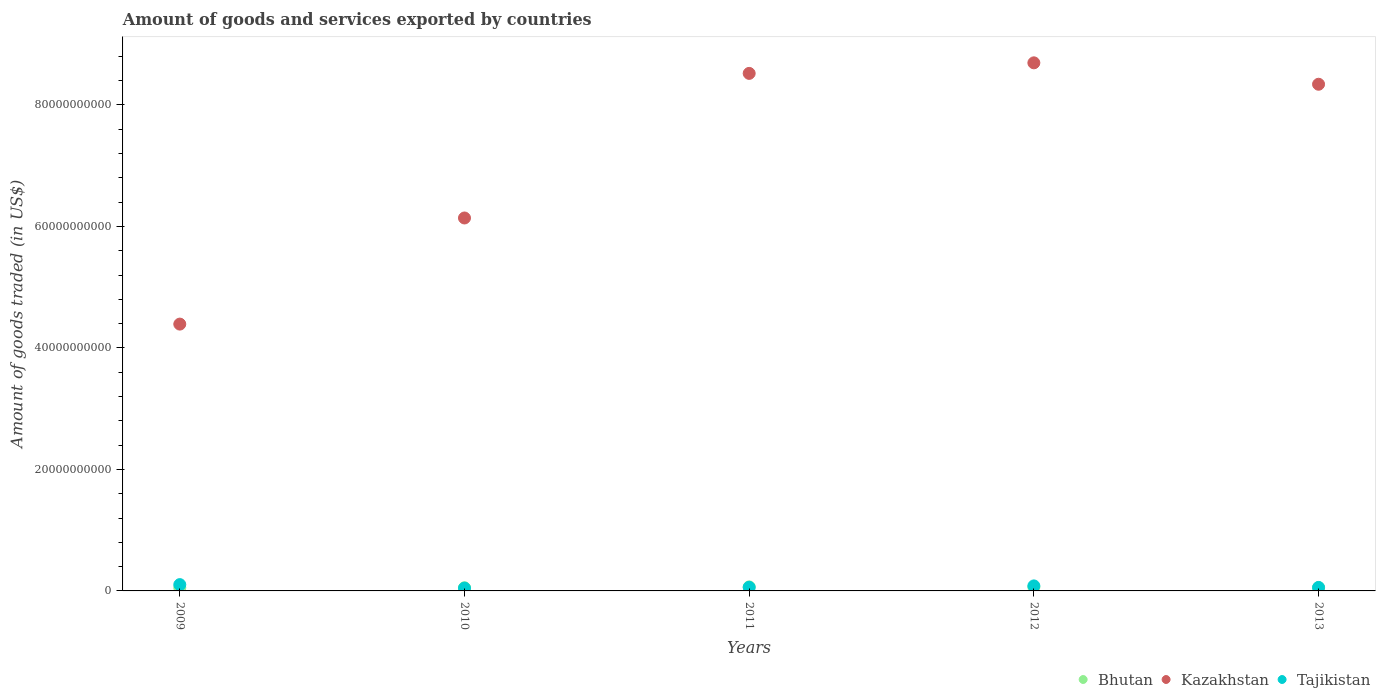What is the total amount of goods and services exported in Tajikistan in 2010?
Offer a very short reply. 4.59e+08. Across all years, what is the maximum total amount of goods and services exported in Kazakhstan?
Give a very brief answer. 8.69e+1. Across all years, what is the minimum total amount of goods and services exported in Tajikistan?
Ensure brevity in your answer.  4.59e+08. What is the total total amount of goods and services exported in Bhutan in the graph?
Give a very brief answer. 2.87e+09. What is the difference between the total amount of goods and services exported in Kazakhstan in 2011 and that in 2013?
Your answer should be compact. 1.79e+09. What is the difference between the total amount of goods and services exported in Tajikistan in 2011 and the total amount of goods and services exported in Kazakhstan in 2010?
Your answer should be compact. -6.08e+1. What is the average total amount of goods and services exported in Kazakhstan per year?
Offer a very short reply. 7.22e+1. In the year 2011, what is the difference between the total amount of goods and services exported in Bhutan and total amount of goods and services exported in Tajikistan?
Provide a succinct answer. 7.03e+07. In how many years, is the total amount of goods and services exported in Tajikistan greater than 24000000000 US$?
Provide a short and direct response. 0. What is the ratio of the total amount of goods and services exported in Kazakhstan in 2012 to that in 2013?
Your answer should be very brief. 1.04. Is the total amount of goods and services exported in Tajikistan in 2011 less than that in 2012?
Your answer should be compact. Yes. What is the difference between the highest and the second highest total amount of goods and services exported in Tajikistan?
Your answer should be very brief. 2.13e+08. What is the difference between the highest and the lowest total amount of goods and services exported in Kazakhstan?
Provide a succinct answer. 4.30e+1. In how many years, is the total amount of goods and services exported in Tajikistan greater than the average total amount of goods and services exported in Tajikistan taken over all years?
Provide a short and direct response. 2. Is the sum of the total amount of goods and services exported in Bhutan in 2010 and 2012 greater than the maximum total amount of goods and services exported in Kazakhstan across all years?
Your answer should be very brief. No. Is it the case that in every year, the sum of the total amount of goods and services exported in Kazakhstan and total amount of goods and services exported in Bhutan  is greater than the total amount of goods and services exported in Tajikistan?
Keep it short and to the point. Yes. Is the total amount of goods and services exported in Bhutan strictly greater than the total amount of goods and services exported in Kazakhstan over the years?
Give a very brief answer. No. How many dotlines are there?
Offer a very short reply. 3. What is the difference between two consecutive major ticks on the Y-axis?
Provide a succinct answer. 2.00e+1. Does the graph contain any zero values?
Ensure brevity in your answer.  No. What is the title of the graph?
Ensure brevity in your answer.  Amount of goods and services exported by countries. What is the label or title of the X-axis?
Make the answer very short. Years. What is the label or title of the Y-axis?
Your response must be concise. Amount of goods traded (in US$). What is the Amount of goods traded (in US$) of Bhutan in 2009?
Give a very brief answer. 5.18e+08. What is the Amount of goods traded (in US$) of Kazakhstan in 2009?
Your answer should be compact. 4.39e+1. What is the Amount of goods traded (in US$) of Tajikistan in 2009?
Make the answer very short. 1.04e+09. What is the Amount of goods traded (in US$) in Bhutan in 2010?
Make the answer very short. 5.22e+08. What is the Amount of goods traded (in US$) in Kazakhstan in 2010?
Offer a very short reply. 6.14e+1. What is the Amount of goods traded (in US$) in Tajikistan in 2010?
Provide a short and direct response. 4.59e+08. What is the Amount of goods traded (in US$) in Bhutan in 2011?
Offer a very short reply. 6.64e+08. What is the Amount of goods traded (in US$) in Kazakhstan in 2011?
Make the answer very short. 8.52e+1. What is the Amount of goods traded (in US$) of Tajikistan in 2011?
Give a very brief answer. 5.93e+08. What is the Amount of goods traded (in US$) of Bhutan in 2012?
Make the answer very short. 6.27e+08. What is the Amount of goods traded (in US$) of Kazakhstan in 2012?
Provide a succinct answer. 8.69e+1. What is the Amount of goods traded (in US$) in Tajikistan in 2012?
Your answer should be compact. 8.26e+08. What is the Amount of goods traded (in US$) in Bhutan in 2013?
Ensure brevity in your answer.  5.44e+08. What is the Amount of goods traded (in US$) of Kazakhstan in 2013?
Ensure brevity in your answer.  8.34e+1. What is the Amount of goods traded (in US$) of Tajikistan in 2013?
Keep it short and to the point. 5.74e+08. Across all years, what is the maximum Amount of goods traded (in US$) of Bhutan?
Give a very brief answer. 6.64e+08. Across all years, what is the maximum Amount of goods traded (in US$) in Kazakhstan?
Your response must be concise. 8.69e+1. Across all years, what is the maximum Amount of goods traded (in US$) in Tajikistan?
Offer a terse response. 1.04e+09. Across all years, what is the minimum Amount of goods traded (in US$) of Bhutan?
Provide a short and direct response. 5.18e+08. Across all years, what is the minimum Amount of goods traded (in US$) in Kazakhstan?
Your answer should be compact. 4.39e+1. Across all years, what is the minimum Amount of goods traded (in US$) of Tajikistan?
Give a very brief answer. 4.59e+08. What is the total Amount of goods traded (in US$) in Bhutan in the graph?
Make the answer very short. 2.87e+09. What is the total Amount of goods traded (in US$) of Kazakhstan in the graph?
Your answer should be very brief. 3.61e+11. What is the total Amount of goods traded (in US$) of Tajikistan in the graph?
Your answer should be very brief. 3.49e+09. What is the difference between the Amount of goods traded (in US$) in Bhutan in 2009 and that in 2010?
Offer a terse response. -3.70e+06. What is the difference between the Amount of goods traded (in US$) of Kazakhstan in 2009 and that in 2010?
Offer a terse response. -1.75e+1. What is the difference between the Amount of goods traded (in US$) in Tajikistan in 2009 and that in 2010?
Keep it short and to the point. 5.79e+08. What is the difference between the Amount of goods traded (in US$) of Bhutan in 2009 and that in 2011?
Provide a succinct answer. -1.46e+08. What is the difference between the Amount of goods traded (in US$) in Kazakhstan in 2009 and that in 2011?
Your answer should be very brief. -4.13e+1. What is the difference between the Amount of goods traded (in US$) in Tajikistan in 2009 and that in 2011?
Offer a terse response. 4.45e+08. What is the difference between the Amount of goods traded (in US$) in Bhutan in 2009 and that in 2012?
Make the answer very short. -1.09e+08. What is the difference between the Amount of goods traded (in US$) of Kazakhstan in 2009 and that in 2012?
Offer a very short reply. -4.30e+1. What is the difference between the Amount of goods traded (in US$) of Tajikistan in 2009 and that in 2012?
Provide a short and direct response. 2.13e+08. What is the difference between the Amount of goods traded (in US$) in Bhutan in 2009 and that in 2013?
Keep it short and to the point. -2.65e+07. What is the difference between the Amount of goods traded (in US$) of Kazakhstan in 2009 and that in 2013?
Your answer should be compact. -3.95e+1. What is the difference between the Amount of goods traded (in US$) in Tajikistan in 2009 and that in 2013?
Keep it short and to the point. 4.64e+08. What is the difference between the Amount of goods traded (in US$) of Bhutan in 2010 and that in 2011?
Your answer should be very brief. -1.42e+08. What is the difference between the Amount of goods traded (in US$) in Kazakhstan in 2010 and that in 2011?
Offer a terse response. -2.38e+1. What is the difference between the Amount of goods traded (in US$) in Tajikistan in 2010 and that in 2011?
Keep it short and to the point. -1.34e+08. What is the difference between the Amount of goods traded (in US$) in Bhutan in 2010 and that in 2012?
Give a very brief answer. -1.05e+08. What is the difference between the Amount of goods traded (in US$) in Kazakhstan in 2010 and that in 2012?
Make the answer very short. -2.55e+1. What is the difference between the Amount of goods traded (in US$) of Tajikistan in 2010 and that in 2012?
Your response must be concise. -3.67e+08. What is the difference between the Amount of goods traded (in US$) in Bhutan in 2010 and that in 2013?
Provide a short and direct response. -2.28e+07. What is the difference between the Amount of goods traded (in US$) in Kazakhstan in 2010 and that in 2013?
Ensure brevity in your answer.  -2.20e+1. What is the difference between the Amount of goods traded (in US$) in Tajikistan in 2010 and that in 2013?
Your response must be concise. -1.15e+08. What is the difference between the Amount of goods traded (in US$) in Bhutan in 2011 and that in 2012?
Provide a short and direct response. 3.68e+07. What is the difference between the Amount of goods traded (in US$) of Kazakhstan in 2011 and that in 2012?
Offer a very short reply. -1.74e+09. What is the difference between the Amount of goods traded (in US$) in Tajikistan in 2011 and that in 2012?
Ensure brevity in your answer.  -2.33e+08. What is the difference between the Amount of goods traded (in US$) in Bhutan in 2011 and that in 2013?
Offer a very short reply. 1.19e+08. What is the difference between the Amount of goods traded (in US$) in Kazakhstan in 2011 and that in 2013?
Your response must be concise. 1.79e+09. What is the difference between the Amount of goods traded (in US$) in Tajikistan in 2011 and that in 2013?
Provide a succinct answer. 1.93e+07. What is the difference between the Amount of goods traded (in US$) in Bhutan in 2012 and that in 2013?
Offer a terse response. 8.24e+07. What is the difference between the Amount of goods traded (in US$) in Kazakhstan in 2012 and that in 2013?
Keep it short and to the point. 3.52e+09. What is the difference between the Amount of goods traded (in US$) in Tajikistan in 2012 and that in 2013?
Your answer should be very brief. 2.52e+08. What is the difference between the Amount of goods traded (in US$) in Bhutan in 2009 and the Amount of goods traded (in US$) in Kazakhstan in 2010?
Make the answer very short. -6.09e+1. What is the difference between the Amount of goods traded (in US$) in Bhutan in 2009 and the Amount of goods traded (in US$) in Tajikistan in 2010?
Provide a short and direct response. 5.88e+07. What is the difference between the Amount of goods traded (in US$) in Kazakhstan in 2009 and the Amount of goods traded (in US$) in Tajikistan in 2010?
Make the answer very short. 4.35e+1. What is the difference between the Amount of goods traded (in US$) in Bhutan in 2009 and the Amount of goods traded (in US$) in Kazakhstan in 2011?
Provide a succinct answer. -8.47e+1. What is the difference between the Amount of goods traded (in US$) in Bhutan in 2009 and the Amount of goods traded (in US$) in Tajikistan in 2011?
Give a very brief answer. -7.54e+07. What is the difference between the Amount of goods traded (in US$) of Kazakhstan in 2009 and the Amount of goods traded (in US$) of Tajikistan in 2011?
Your response must be concise. 4.33e+1. What is the difference between the Amount of goods traded (in US$) in Bhutan in 2009 and the Amount of goods traded (in US$) in Kazakhstan in 2012?
Your response must be concise. -8.64e+1. What is the difference between the Amount of goods traded (in US$) in Bhutan in 2009 and the Amount of goods traded (in US$) in Tajikistan in 2012?
Your answer should be compact. -3.08e+08. What is the difference between the Amount of goods traded (in US$) in Kazakhstan in 2009 and the Amount of goods traded (in US$) in Tajikistan in 2012?
Your answer should be compact. 4.31e+1. What is the difference between the Amount of goods traded (in US$) in Bhutan in 2009 and the Amount of goods traded (in US$) in Kazakhstan in 2013?
Provide a succinct answer. -8.29e+1. What is the difference between the Amount of goods traded (in US$) in Bhutan in 2009 and the Amount of goods traded (in US$) in Tajikistan in 2013?
Your answer should be compact. -5.61e+07. What is the difference between the Amount of goods traded (in US$) in Kazakhstan in 2009 and the Amount of goods traded (in US$) in Tajikistan in 2013?
Your answer should be compact. 4.33e+1. What is the difference between the Amount of goods traded (in US$) in Bhutan in 2010 and the Amount of goods traded (in US$) in Kazakhstan in 2011?
Provide a succinct answer. -8.47e+1. What is the difference between the Amount of goods traded (in US$) in Bhutan in 2010 and the Amount of goods traded (in US$) in Tajikistan in 2011?
Ensure brevity in your answer.  -7.17e+07. What is the difference between the Amount of goods traded (in US$) in Kazakhstan in 2010 and the Amount of goods traded (in US$) in Tajikistan in 2011?
Offer a terse response. 6.08e+1. What is the difference between the Amount of goods traded (in US$) in Bhutan in 2010 and the Amount of goods traded (in US$) in Kazakhstan in 2012?
Offer a very short reply. -8.64e+1. What is the difference between the Amount of goods traded (in US$) of Bhutan in 2010 and the Amount of goods traded (in US$) of Tajikistan in 2012?
Your answer should be compact. -3.04e+08. What is the difference between the Amount of goods traded (in US$) of Kazakhstan in 2010 and the Amount of goods traded (in US$) of Tajikistan in 2012?
Your answer should be compact. 6.06e+1. What is the difference between the Amount of goods traded (in US$) in Bhutan in 2010 and the Amount of goods traded (in US$) in Kazakhstan in 2013?
Offer a very short reply. -8.29e+1. What is the difference between the Amount of goods traded (in US$) in Bhutan in 2010 and the Amount of goods traded (in US$) in Tajikistan in 2013?
Your answer should be compact. -5.24e+07. What is the difference between the Amount of goods traded (in US$) in Kazakhstan in 2010 and the Amount of goods traded (in US$) in Tajikistan in 2013?
Make the answer very short. 6.08e+1. What is the difference between the Amount of goods traded (in US$) of Bhutan in 2011 and the Amount of goods traded (in US$) of Kazakhstan in 2012?
Offer a very short reply. -8.63e+1. What is the difference between the Amount of goods traded (in US$) of Bhutan in 2011 and the Amount of goods traded (in US$) of Tajikistan in 2012?
Make the answer very short. -1.62e+08. What is the difference between the Amount of goods traded (in US$) of Kazakhstan in 2011 and the Amount of goods traded (in US$) of Tajikistan in 2012?
Your answer should be very brief. 8.44e+1. What is the difference between the Amount of goods traded (in US$) in Bhutan in 2011 and the Amount of goods traded (in US$) in Kazakhstan in 2013?
Your response must be concise. -8.27e+1. What is the difference between the Amount of goods traded (in US$) of Bhutan in 2011 and the Amount of goods traded (in US$) of Tajikistan in 2013?
Provide a short and direct response. 8.96e+07. What is the difference between the Amount of goods traded (in US$) in Kazakhstan in 2011 and the Amount of goods traded (in US$) in Tajikistan in 2013?
Keep it short and to the point. 8.46e+1. What is the difference between the Amount of goods traded (in US$) in Bhutan in 2012 and the Amount of goods traded (in US$) in Kazakhstan in 2013?
Keep it short and to the point. -8.28e+1. What is the difference between the Amount of goods traded (in US$) in Bhutan in 2012 and the Amount of goods traded (in US$) in Tajikistan in 2013?
Provide a succinct answer. 5.28e+07. What is the difference between the Amount of goods traded (in US$) of Kazakhstan in 2012 and the Amount of goods traded (in US$) of Tajikistan in 2013?
Your response must be concise. 8.64e+1. What is the average Amount of goods traded (in US$) in Bhutan per year?
Offer a very short reply. 5.75e+08. What is the average Amount of goods traded (in US$) in Kazakhstan per year?
Keep it short and to the point. 7.22e+1. What is the average Amount of goods traded (in US$) in Tajikistan per year?
Provide a succinct answer. 6.98e+08. In the year 2009, what is the difference between the Amount of goods traded (in US$) in Bhutan and Amount of goods traded (in US$) in Kazakhstan?
Keep it short and to the point. -4.34e+1. In the year 2009, what is the difference between the Amount of goods traded (in US$) of Bhutan and Amount of goods traded (in US$) of Tajikistan?
Keep it short and to the point. -5.21e+08. In the year 2009, what is the difference between the Amount of goods traded (in US$) of Kazakhstan and Amount of goods traded (in US$) of Tajikistan?
Your answer should be compact. 4.29e+1. In the year 2010, what is the difference between the Amount of goods traded (in US$) in Bhutan and Amount of goods traded (in US$) in Kazakhstan?
Give a very brief answer. -6.09e+1. In the year 2010, what is the difference between the Amount of goods traded (in US$) of Bhutan and Amount of goods traded (in US$) of Tajikistan?
Keep it short and to the point. 6.25e+07. In the year 2010, what is the difference between the Amount of goods traded (in US$) of Kazakhstan and Amount of goods traded (in US$) of Tajikistan?
Provide a short and direct response. 6.09e+1. In the year 2011, what is the difference between the Amount of goods traded (in US$) of Bhutan and Amount of goods traded (in US$) of Kazakhstan?
Offer a terse response. -8.45e+1. In the year 2011, what is the difference between the Amount of goods traded (in US$) of Bhutan and Amount of goods traded (in US$) of Tajikistan?
Your response must be concise. 7.03e+07. In the year 2011, what is the difference between the Amount of goods traded (in US$) of Kazakhstan and Amount of goods traded (in US$) of Tajikistan?
Provide a succinct answer. 8.46e+1. In the year 2012, what is the difference between the Amount of goods traded (in US$) of Bhutan and Amount of goods traded (in US$) of Kazakhstan?
Ensure brevity in your answer.  -8.63e+1. In the year 2012, what is the difference between the Amount of goods traded (in US$) in Bhutan and Amount of goods traded (in US$) in Tajikistan?
Your answer should be very brief. -1.99e+08. In the year 2012, what is the difference between the Amount of goods traded (in US$) of Kazakhstan and Amount of goods traded (in US$) of Tajikistan?
Your response must be concise. 8.61e+1. In the year 2013, what is the difference between the Amount of goods traded (in US$) in Bhutan and Amount of goods traded (in US$) in Kazakhstan?
Provide a short and direct response. -8.29e+1. In the year 2013, what is the difference between the Amount of goods traded (in US$) of Bhutan and Amount of goods traded (in US$) of Tajikistan?
Offer a very short reply. -2.96e+07. In the year 2013, what is the difference between the Amount of goods traded (in US$) in Kazakhstan and Amount of goods traded (in US$) in Tajikistan?
Ensure brevity in your answer.  8.28e+1. What is the ratio of the Amount of goods traded (in US$) in Kazakhstan in 2009 to that in 2010?
Keep it short and to the point. 0.72. What is the ratio of the Amount of goods traded (in US$) in Tajikistan in 2009 to that in 2010?
Make the answer very short. 2.26. What is the ratio of the Amount of goods traded (in US$) of Bhutan in 2009 to that in 2011?
Provide a succinct answer. 0.78. What is the ratio of the Amount of goods traded (in US$) of Kazakhstan in 2009 to that in 2011?
Give a very brief answer. 0.52. What is the ratio of the Amount of goods traded (in US$) in Tajikistan in 2009 to that in 2011?
Ensure brevity in your answer.  1.75. What is the ratio of the Amount of goods traded (in US$) of Bhutan in 2009 to that in 2012?
Offer a terse response. 0.83. What is the ratio of the Amount of goods traded (in US$) in Kazakhstan in 2009 to that in 2012?
Provide a short and direct response. 0.51. What is the ratio of the Amount of goods traded (in US$) in Tajikistan in 2009 to that in 2012?
Your answer should be very brief. 1.26. What is the ratio of the Amount of goods traded (in US$) of Bhutan in 2009 to that in 2013?
Your answer should be compact. 0.95. What is the ratio of the Amount of goods traded (in US$) in Kazakhstan in 2009 to that in 2013?
Keep it short and to the point. 0.53. What is the ratio of the Amount of goods traded (in US$) in Tajikistan in 2009 to that in 2013?
Offer a very short reply. 1.81. What is the ratio of the Amount of goods traded (in US$) of Bhutan in 2010 to that in 2011?
Provide a succinct answer. 0.79. What is the ratio of the Amount of goods traded (in US$) of Kazakhstan in 2010 to that in 2011?
Your answer should be very brief. 0.72. What is the ratio of the Amount of goods traded (in US$) in Tajikistan in 2010 to that in 2011?
Provide a short and direct response. 0.77. What is the ratio of the Amount of goods traded (in US$) of Bhutan in 2010 to that in 2012?
Offer a terse response. 0.83. What is the ratio of the Amount of goods traded (in US$) in Kazakhstan in 2010 to that in 2012?
Provide a succinct answer. 0.71. What is the ratio of the Amount of goods traded (in US$) in Tajikistan in 2010 to that in 2012?
Make the answer very short. 0.56. What is the ratio of the Amount of goods traded (in US$) in Bhutan in 2010 to that in 2013?
Offer a terse response. 0.96. What is the ratio of the Amount of goods traded (in US$) of Kazakhstan in 2010 to that in 2013?
Ensure brevity in your answer.  0.74. What is the ratio of the Amount of goods traded (in US$) of Tajikistan in 2010 to that in 2013?
Provide a succinct answer. 0.8. What is the ratio of the Amount of goods traded (in US$) in Bhutan in 2011 to that in 2012?
Offer a very short reply. 1.06. What is the ratio of the Amount of goods traded (in US$) of Tajikistan in 2011 to that in 2012?
Your response must be concise. 0.72. What is the ratio of the Amount of goods traded (in US$) in Bhutan in 2011 to that in 2013?
Offer a very short reply. 1.22. What is the ratio of the Amount of goods traded (in US$) of Kazakhstan in 2011 to that in 2013?
Keep it short and to the point. 1.02. What is the ratio of the Amount of goods traded (in US$) of Tajikistan in 2011 to that in 2013?
Offer a terse response. 1.03. What is the ratio of the Amount of goods traded (in US$) in Bhutan in 2012 to that in 2013?
Offer a terse response. 1.15. What is the ratio of the Amount of goods traded (in US$) of Kazakhstan in 2012 to that in 2013?
Provide a succinct answer. 1.04. What is the ratio of the Amount of goods traded (in US$) of Tajikistan in 2012 to that in 2013?
Offer a terse response. 1.44. What is the difference between the highest and the second highest Amount of goods traded (in US$) of Bhutan?
Ensure brevity in your answer.  3.68e+07. What is the difference between the highest and the second highest Amount of goods traded (in US$) of Kazakhstan?
Your answer should be very brief. 1.74e+09. What is the difference between the highest and the second highest Amount of goods traded (in US$) of Tajikistan?
Your answer should be very brief. 2.13e+08. What is the difference between the highest and the lowest Amount of goods traded (in US$) in Bhutan?
Offer a terse response. 1.46e+08. What is the difference between the highest and the lowest Amount of goods traded (in US$) in Kazakhstan?
Keep it short and to the point. 4.30e+1. What is the difference between the highest and the lowest Amount of goods traded (in US$) in Tajikistan?
Provide a short and direct response. 5.79e+08. 